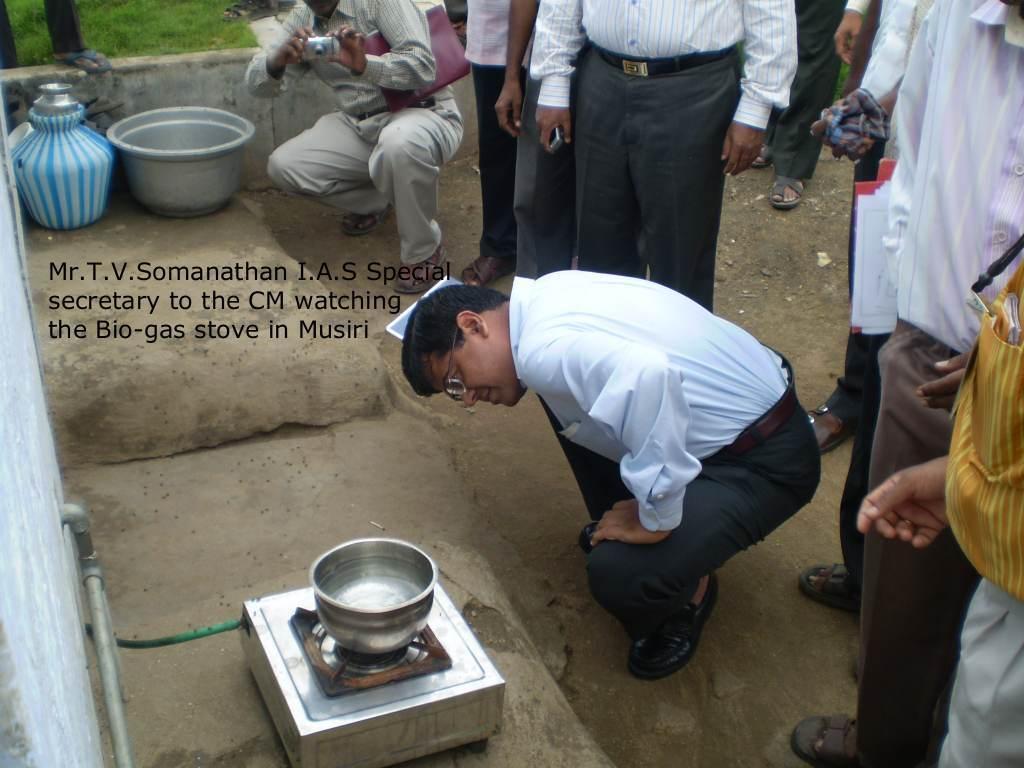Please provide a concise description of this image. In this image there is a stove in the middle. On the stove there is a pan. Beside it there is a man who is sitting in the squat position and looking at the stove. Behind him there are so many people who are standing on the ground. At the top there is a man taking the pictures with the camera. Beside him there is a tub and a vessel. 